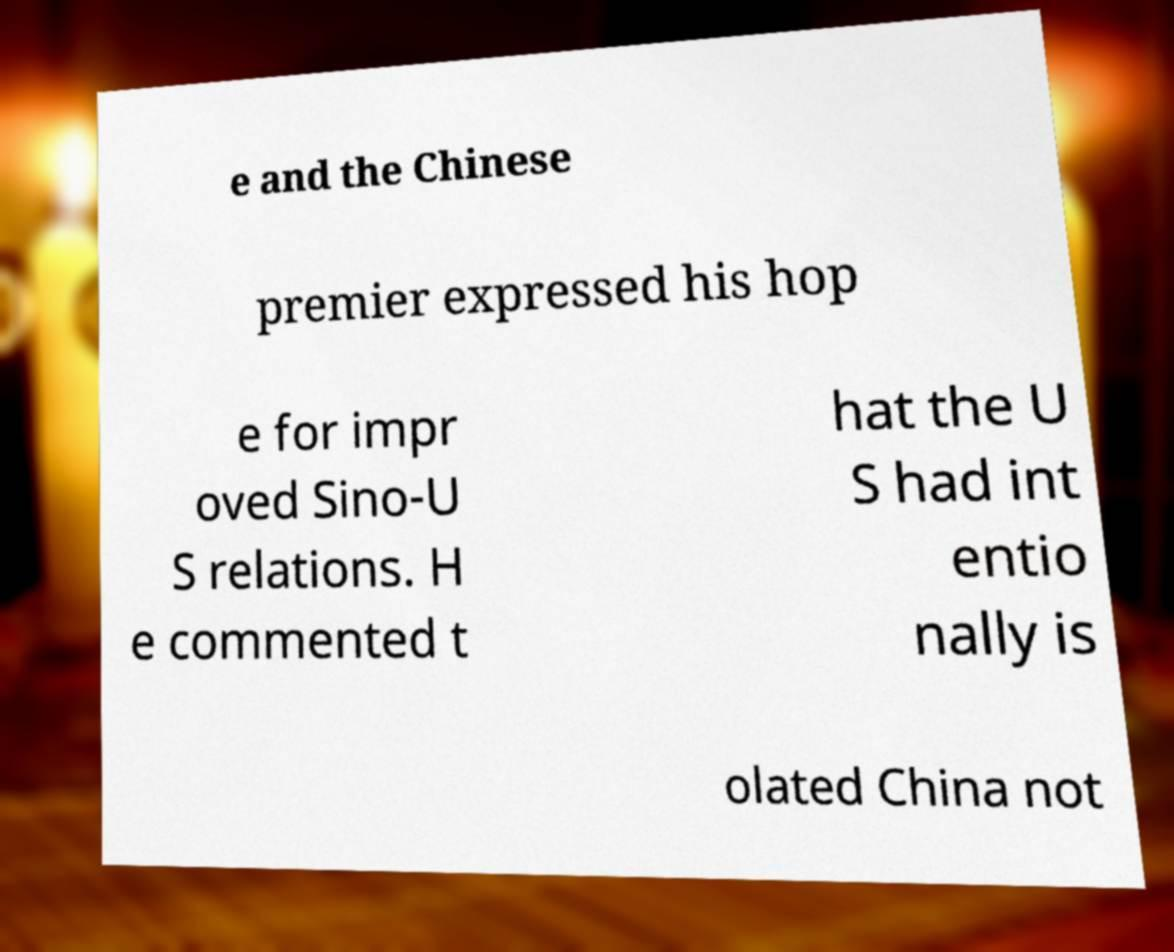There's text embedded in this image that I need extracted. Can you transcribe it verbatim? e and the Chinese premier expressed his hop e for impr oved Sino-U S relations. H e commented t hat the U S had int entio nally is olated China not 